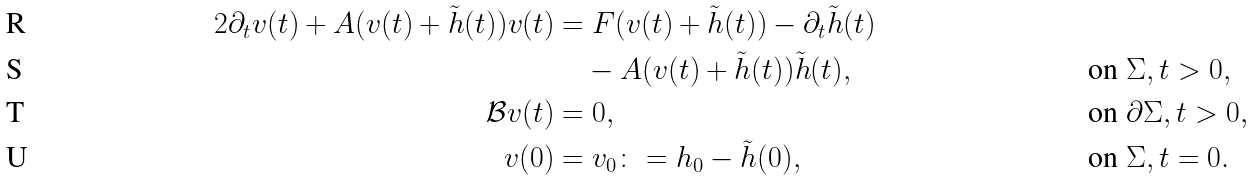Convert formula to latex. <formula><loc_0><loc_0><loc_500><loc_500>{ 2 } \partial _ { t } v ( t ) + A ( v ( t ) + \tilde { h } ( t ) ) v ( t ) & = F ( v ( t ) + \tilde { h } ( t ) ) - \partial _ { t } \tilde { h } ( t ) \\ & \quad - A ( v ( t ) + \tilde { h } ( t ) ) \tilde { h } ( t ) , \quad & & \text {on } \Sigma , t > 0 , \\ \mathcal { B } v ( t ) & = 0 , & & \text {on } \partial \Sigma , t > 0 , \\ v ( 0 ) & = v _ { 0 } \colon = h _ { 0 } - \tilde { h } ( 0 ) , & & \text {on } \Sigma , t = 0 .</formula> 